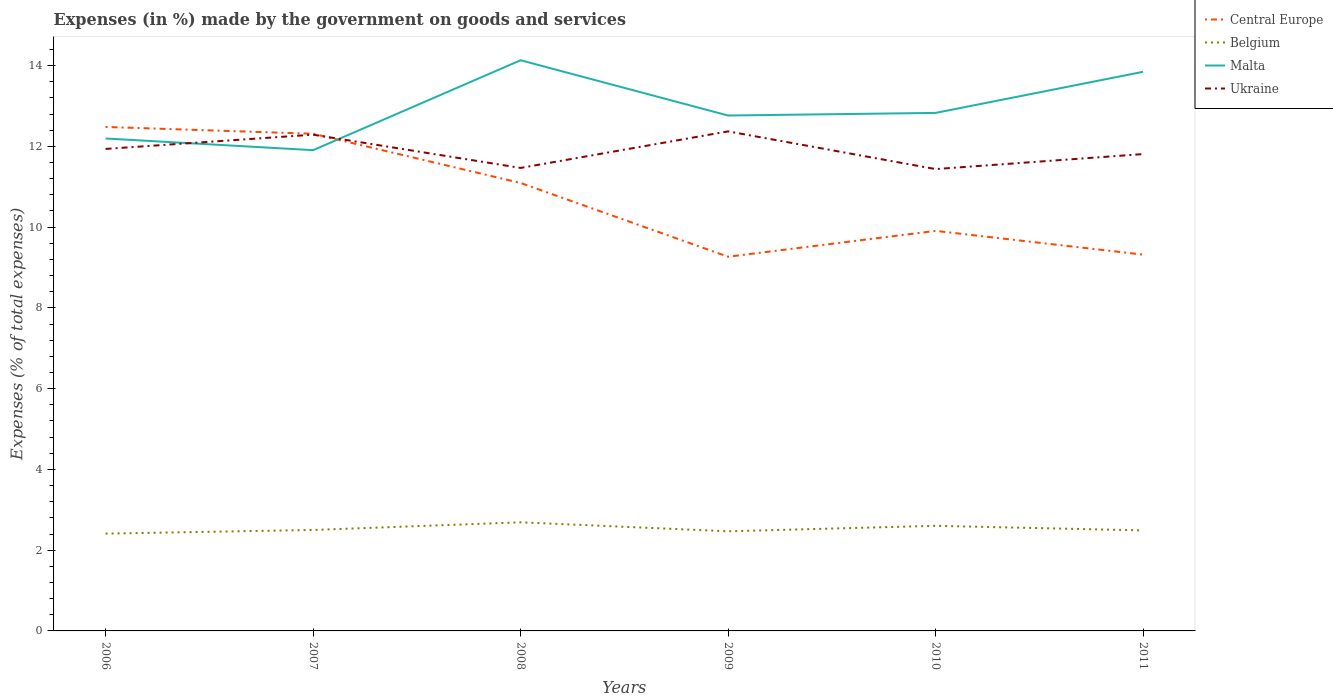How many different coloured lines are there?
Offer a very short reply. 4. Is the number of lines equal to the number of legend labels?
Your answer should be compact. Yes. Across all years, what is the maximum percentage of expenses made by the government on goods and services in Central Europe?
Make the answer very short. 9.27. In which year was the percentage of expenses made by the government on goods and services in Belgium maximum?
Ensure brevity in your answer.  2006. What is the total percentage of expenses made by the government on goods and services in Central Europe in the graph?
Make the answer very short. -0.05. What is the difference between the highest and the second highest percentage of expenses made by the government on goods and services in Ukraine?
Your response must be concise. 0.93. How many lines are there?
Ensure brevity in your answer.  4. Does the graph contain any zero values?
Make the answer very short. No. What is the title of the graph?
Your answer should be very brief. Expenses (in %) made by the government on goods and services. Does "East Asia (developing only)" appear as one of the legend labels in the graph?
Your answer should be compact. No. What is the label or title of the X-axis?
Your answer should be compact. Years. What is the label or title of the Y-axis?
Make the answer very short. Expenses (% of total expenses). What is the Expenses (% of total expenses) of Central Europe in 2006?
Your answer should be very brief. 12.48. What is the Expenses (% of total expenses) of Belgium in 2006?
Offer a very short reply. 2.41. What is the Expenses (% of total expenses) in Malta in 2006?
Offer a very short reply. 12.19. What is the Expenses (% of total expenses) of Ukraine in 2006?
Your answer should be compact. 11.94. What is the Expenses (% of total expenses) in Central Europe in 2007?
Your answer should be very brief. 12.31. What is the Expenses (% of total expenses) of Belgium in 2007?
Give a very brief answer. 2.5. What is the Expenses (% of total expenses) in Malta in 2007?
Provide a succinct answer. 11.91. What is the Expenses (% of total expenses) in Ukraine in 2007?
Your answer should be compact. 12.29. What is the Expenses (% of total expenses) in Central Europe in 2008?
Your answer should be compact. 11.09. What is the Expenses (% of total expenses) of Belgium in 2008?
Provide a short and direct response. 2.69. What is the Expenses (% of total expenses) in Malta in 2008?
Ensure brevity in your answer.  14.13. What is the Expenses (% of total expenses) of Ukraine in 2008?
Provide a short and direct response. 11.47. What is the Expenses (% of total expenses) in Central Europe in 2009?
Offer a very short reply. 9.27. What is the Expenses (% of total expenses) of Belgium in 2009?
Provide a succinct answer. 2.47. What is the Expenses (% of total expenses) in Malta in 2009?
Your response must be concise. 12.76. What is the Expenses (% of total expenses) in Ukraine in 2009?
Your answer should be very brief. 12.37. What is the Expenses (% of total expenses) in Central Europe in 2010?
Your answer should be very brief. 9.91. What is the Expenses (% of total expenses) in Belgium in 2010?
Offer a terse response. 2.6. What is the Expenses (% of total expenses) of Malta in 2010?
Make the answer very short. 12.83. What is the Expenses (% of total expenses) of Ukraine in 2010?
Make the answer very short. 11.44. What is the Expenses (% of total expenses) of Central Europe in 2011?
Offer a terse response. 9.32. What is the Expenses (% of total expenses) of Belgium in 2011?
Provide a succinct answer. 2.49. What is the Expenses (% of total expenses) of Malta in 2011?
Offer a very short reply. 13.85. What is the Expenses (% of total expenses) in Ukraine in 2011?
Your response must be concise. 11.81. Across all years, what is the maximum Expenses (% of total expenses) in Central Europe?
Make the answer very short. 12.48. Across all years, what is the maximum Expenses (% of total expenses) of Belgium?
Ensure brevity in your answer.  2.69. Across all years, what is the maximum Expenses (% of total expenses) of Malta?
Your answer should be very brief. 14.13. Across all years, what is the maximum Expenses (% of total expenses) of Ukraine?
Ensure brevity in your answer.  12.37. Across all years, what is the minimum Expenses (% of total expenses) in Central Europe?
Offer a terse response. 9.27. Across all years, what is the minimum Expenses (% of total expenses) in Belgium?
Your answer should be very brief. 2.41. Across all years, what is the minimum Expenses (% of total expenses) of Malta?
Your answer should be compact. 11.91. Across all years, what is the minimum Expenses (% of total expenses) of Ukraine?
Your response must be concise. 11.44. What is the total Expenses (% of total expenses) of Central Europe in the graph?
Your response must be concise. 64.37. What is the total Expenses (% of total expenses) of Belgium in the graph?
Provide a succinct answer. 15.16. What is the total Expenses (% of total expenses) of Malta in the graph?
Offer a terse response. 77.67. What is the total Expenses (% of total expenses) in Ukraine in the graph?
Your answer should be compact. 71.3. What is the difference between the Expenses (% of total expenses) in Central Europe in 2006 and that in 2007?
Give a very brief answer. 0.17. What is the difference between the Expenses (% of total expenses) of Belgium in 2006 and that in 2007?
Provide a succinct answer. -0.09. What is the difference between the Expenses (% of total expenses) in Malta in 2006 and that in 2007?
Offer a very short reply. 0.29. What is the difference between the Expenses (% of total expenses) of Ukraine in 2006 and that in 2007?
Your answer should be compact. -0.35. What is the difference between the Expenses (% of total expenses) of Central Europe in 2006 and that in 2008?
Your answer should be very brief. 1.39. What is the difference between the Expenses (% of total expenses) of Belgium in 2006 and that in 2008?
Offer a very short reply. -0.28. What is the difference between the Expenses (% of total expenses) in Malta in 2006 and that in 2008?
Ensure brevity in your answer.  -1.94. What is the difference between the Expenses (% of total expenses) of Ukraine in 2006 and that in 2008?
Keep it short and to the point. 0.47. What is the difference between the Expenses (% of total expenses) in Central Europe in 2006 and that in 2009?
Your answer should be compact. 3.21. What is the difference between the Expenses (% of total expenses) of Belgium in 2006 and that in 2009?
Ensure brevity in your answer.  -0.06. What is the difference between the Expenses (% of total expenses) of Malta in 2006 and that in 2009?
Offer a terse response. -0.57. What is the difference between the Expenses (% of total expenses) of Ukraine in 2006 and that in 2009?
Keep it short and to the point. -0.43. What is the difference between the Expenses (% of total expenses) of Central Europe in 2006 and that in 2010?
Offer a terse response. 2.57. What is the difference between the Expenses (% of total expenses) in Belgium in 2006 and that in 2010?
Your response must be concise. -0.19. What is the difference between the Expenses (% of total expenses) of Malta in 2006 and that in 2010?
Provide a succinct answer. -0.63. What is the difference between the Expenses (% of total expenses) in Ukraine in 2006 and that in 2010?
Your answer should be compact. 0.5. What is the difference between the Expenses (% of total expenses) in Central Europe in 2006 and that in 2011?
Keep it short and to the point. 3.16. What is the difference between the Expenses (% of total expenses) of Belgium in 2006 and that in 2011?
Your answer should be very brief. -0.08. What is the difference between the Expenses (% of total expenses) of Malta in 2006 and that in 2011?
Your response must be concise. -1.65. What is the difference between the Expenses (% of total expenses) in Ukraine in 2006 and that in 2011?
Keep it short and to the point. 0.13. What is the difference between the Expenses (% of total expenses) of Central Europe in 2007 and that in 2008?
Your response must be concise. 1.22. What is the difference between the Expenses (% of total expenses) in Belgium in 2007 and that in 2008?
Your response must be concise. -0.19. What is the difference between the Expenses (% of total expenses) in Malta in 2007 and that in 2008?
Provide a succinct answer. -2.23. What is the difference between the Expenses (% of total expenses) of Ukraine in 2007 and that in 2008?
Offer a very short reply. 0.82. What is the difference between the Expenses (% of total expenses) of Central Europe in 2007 and that in 2009?
Provide a short and direct response. 3.04. What is the difference between the Expenses (% of total expenses) of Belgium in 2007 and that in 2009?
Offer a terse response. 0.03. What is the difference between the Expenses (% of total expenses) of Malta in 2007 and that in 2009?
Your answer should be very brief. -0.86. What is the difference between the Expenses (% of total expenses) in Ukraine in 2007 and that in 2009?
Your answer should be compact. -0.08. What is the difference between the Expenses (% of total expenses) of Central Europe in 2007 and that in 2010?
Keep it short and to the point. 2.4. What is the difference between the Expenses (% of total expenses) of Belgium in 2007 and that in 2010?
Make the answer very short. -0.1. What is the difference between the Expenses (% of total expenses) of Malta in 2007 and that in 2010?
Ensure brevity in your answer.  -0.92. What is the difference between the Expenses (% of total expenses) of Ukraine in 2007 and that in 2010?
Provide a short and direct response. 0.85. What is the difference between the Expenses (% of total expenses) of Central Europe in 2007 and that in 2011?
Ensure brevity in your answer.  2.99. What is the difference between the Expenses (% of total expenses) in Belgium in 2007 and that in 2011?
Offer a very short reply. 0.01. What is the difference between the Expenses (% of total expenses) in Malta in 2007 and that in 2011?
Keep it short and to the point. -1.94. What is the difference between the Expenses (% of total expenses) in Ukraine in 2007 and that in 2011?
Ensure brevity in your answer.  0.48. What is the difference between the Expenses (% of total expenses) in Central Europe in 2008 and that in 2009?
Keep it short and to the point. 1.83. What is the difference between the Expenses (% of total expenses) of Belgium in 2008 and that in 2009?
Your response must be concise. 0.22. What is the difference between the Expenses (% of total expenses) of Malta in 2008 and that in 2009?
Offer a very short reply. 1.37. What is the difference between the Expenses (% of total expenses) in Ukraine in 2008 and that in 2009?
Your answer should be compact. -0.91. What is the difference between the Expenses (% of total expenses) in Central Europe in 2008 and that in 2010?
Your answer should be very brief. 1.19. What is the difference between the Expenses (% of total expenses) of Belgium in 2008 and that in 2010?
Your response must be concise. 0.09. What is the difference between the Expenses (% of total expenses) of Malta in 2008 and that in 2010?
Offer a very short reply. 1.3. What is the difference between the Expenses (% of total expenses) of Ukraine in 2008 and that in 2010?
Give a very brief answer. 0.03. What is the difference between the Expenses (% of total expenses) of Central Europe in 2008 and that in 2011?
Keep it short and to the point. 1.77. What is the difference between the Expenses (% of total expenses) in Belgium in 2008 and that in 2011?
Your response must be concise. 0.2. What is the difference between the Expenses (% of total expenses) in Malta in 2008 and that in 2011?
Provide a short and direct response. 0.29. What is the difference between the Expenses (% of total expenses) of Ukraine in 2008 and that in 2011?
Keep it short and to the point. -0.34. What is the difference between the Expenses (% of total expenses) of Central Europe in 2009 and that in 2010?
Offer a very short reply. -0.64. What is the difference between the Expenses (% of total expenses) of Belgium in 2009 and that in 2010?
Offer a terse response. -0.14. What is the difference between the Expenses (% of total expenses) of Malta in 2009 and that in 2010?
Your response must be concise. -0.06. What is the difference between the Expenses (% of total expenses) of Ukraine in 2009 and that in 2010?
Offer a very short reply. 0.93. What is the difference between the Expenses (% of total expenses) of Central Europe in 2009 and that in 2011?
Provide a succinct answer. -0.05. What is the difference between the Expenses (% of total expenses) in Belgium in 2009 and that in 2011?
Your answer should be very brief. -0.02. What is the difference between the Expenses (% of total expenses) in Malta in 2009 and that in 2011?
Your answer should be compact. -1.08. What is the difference between the Expenses (% of total expenses) of Ukraine in 2009 and that in 2011?
Ensure brevity in your answer.  0.56. What is the difference between the Expenses (% of total expenses) in Central Europe in 2010 and that in 2011?
Ensure brevity in your answer.  0.59. What is the difference between the Expenses (% of total expenses) in Belgium in 2010 and that in 2011?
Provide a succinct answer. 0.11. What is the difference between the Expenses (% of total expenses) of Malta in 2010 and that in 2011?
Offer a very short reply. -1.02. What is the difference between the Expenses (% of total expenses) of Ukraine in 2010 and that in 2011?
Keep it short and to the point. -0.37. What is the difference between the Expenses (% of total expenses) of Central Europe in 2006 and the Expenses (% of total expenses) of Belgium in 2007?
Provide a short and direct response. 9.98. What is the difference between the Expenses (% of total expenses) of Central Europe in 2006 and the Expenses (% of total expenses) of Malta in 2007?
Make the answer very short. 0.57. What is the difference between the Expenses (% of total expenses) of Central Europe in 2006 and the Expenses (% of total expenses) of Ukraine in 2007?
Provide a succinct answer. 0.19. What is the difference between the Expenses (% of total expenses) of Belgium in 2006 and the Expenses (% of total expenses) of Malta in 2007?
Offer a terse response. -9.5. What is the difference between the Expenses (% of total expenses) of Belgium in 2006 and the Expenses (% of total expenses) of Ukraine in 2007?
Provide a short and direct response. -9.88. What is the difference between the Expenses (% of total expenses) of Malta in 2006 and the Expenses (% of total expenses) of Ukraine in 2007?
Offer a very short reply. -0.09. What is the difference between the Expenses (% of total expenses) in Central Europe in 2006 and the Expenses (% of total expenses) in Belgium in 2008?
Your answer should be very brief. 9.79. What is the difference between the Expenses (% of total expenses) of Central Europe in 2006 and the Expenses (% of total expenses) of Malta in 2008?
Give a very brief answer. -1.65. What is the difference between the Expenses (% of total expenses) in Central Europe in 2006 and the Expenses (% of total expenses) in Ukraine in 2008?
Your answer should be very brief. 1.01. What is the difference between the Expenses (% of total expenses) of Belgium in 2006 and the Expenses (% of total expenses) of Malta in 2008?
Make the answer very short. -11.72. What is the difference between the Expenses (% of total expenses) of Belgium in 2006 and the Expenses (% of total expenses) of Ukraine in 2008?
Give a very brief answer. -9.06. What is the difference between the Expenses (% of total expenses) of Malta in 2006 and the Expenses (% of total expenses) of Ukraine in 2008?
Your answer should be compact. 0.73. What is the difference between the Expenses (% of total expenses) of Central Europe in 2006 and the Expenses (% of total expenses) of Belgium in 2009?
Your response must be concise. 10.01. What is the difference between the Expenses (% of total expenses) of Central Europe in 2006 and the Expenses (% of total expenses) of Malta in 2009?
Ensure brevity in your answer.  -0.28. What is the difference between the Expenses (% of total expenses) in Central Europe in 2006 and the Expenses (% of total expenses) in Ukraine in 2009?
Offer a very short reply. 0.11. What is the difference between the Expenses (% of total expenses) in Belgium in 2006 and the Expenses (% of total expenses) in Malta in 2009?
Your response must be concise. -10.35. What is the difference between the Expenses (% of total expenses) of Belgium in 2006 and the Expenses (% of total expenses) of Ukraine in 2009?
Your answer should be compact. -9.96. What is the difference between the Expenses (% of total expenses) in Malta in 2006 and the Expenses (% of total expenses) in Ukraine in 2009?
Keep it short and to the point. -0.18. What is the difference between the Expenses (% of total expenses) of Central Europe in 2006 and the Expenses (% of total expenses) of Belgium in 2010?
Your response must be concise. 9.88. What is the difference between the Expenses (% of total expenses) of Central Europe in 2006 and the Expenses (% of total expenses) of Malta in 2010?
Keep it short and to the point. -0.35. What is the difference between the Expenses (% of total expenses) in Central Europe in 2006 and the Expenses (% of total expenses) in Ukraine in 2010?
Provide a succinct answer. 1.04. What is the difference between the Expenses (% of total expenses) in Belgium in 2006 and the Expenses (% of total expenses) in Malta in 2010?
Your response must be concise. -10.42. What is the difference between the Expenses (% of total expenses) in Belgium in 2006 and the Expenses (% of total expenses) in Ukraine in 2010?
Your answer should be very brief. -9.03. What is the difference between the Expenses (% of total expenses) of Malta in 2006 and the Expenses (% of total expenses) of Ukraine in 2010?
Your answer should be compact. 0.76. What is the difference between the Expenses (% of total expenses) of Central Europe in 2006 and the Expenses (% of total expenses) of Belgium in 2011?
Provide a succinct answer. 9.99. What is the difference between the Expenses (% of total expenses) of Central Europe in 2006 and the Expenses (% of total expenses) of Malta in 2011?
Provide a succinct answer. -1.37. What is the difference between the Expenses (% of total expenses) of Central Europe in 2006 and the Expenses (% of total expenses) of Ukraine in 2011?
Your answer should be very brief. 0.67. What is the difference between the Expenses (% of total expenses) in Belgium in 2006 and the Expenses (% of total expenses) in Malta in 2011?
Your response must be concise. -11.44. What is the difference between the Expenses (% of total expenses) in Belgium in 2006 and the Expenses (% of total expenses) in Ukraine in 2011?
Make the answer very short. -9.4. What is the difference between the Expenses (% of total expenses) of Malta in 2006 and the Expenses (% of total expenses) of Ukraine in 2011?
Give a very brief answer. 0.39. What is the difference between the Expenses (% of total expenses) in Central Europe in 2007 and the Expenses (% of total expenses) in Belgium in 2008?
Ensure brevity in your answer.  9.62. What is the difference between the Expenses (% of total expenses) in Central Europe in 2007 and the Expenses (% of total expenses) in Malta in 2008?
Your response must be concise. -1.82. What is the difference between the Expenses (% of total expenses) of Central Europe in 2007 and the Expenses (% of total expenses) of Ukraine in 2008?
Provide a succinct answer. 0.85. What is the difference between the Expenses (% of total expenses) in Belgium in 2007 and the Expenses (% of total expenses) in Malta in 2008?
Your answer should be compact. -11.63. What is the difference between the Expenses (% of total expenses) of Belgium in 2007 and the Expenses (% of total expenses) of Ukraine in 2008?
Your answer should be compact. -8.96. What is the difference between the Expenses (% of total expenses) of Malta in 2007 and the Expenses (% of total expenses) of Ukraine in 2008?
Your response must be concise. 0.44. What is the difference between the Expenses (% of total expenses) in Central Europe in 2007 and the Expenses (% of total expenses) in Belgium in 2009?
Make the answer very short. 9.84. What is the difference between the Expenses (% of total expenses) in Central Europe in 2007 and the Expenses (% of total expenses) in Malta in 2009?
Your answer should be compact. -0.45. What is the difference between the Expenses (% of total expenses) in Central Europe in 2007 and the Expenses (% of total expenses) in Ukraine in 2009?
Your response must be concise. -0.06. What is the difference between the Expenses (% of total expenses) in Belgium in 2007 and the Expenses (% of total expenses) in Malta in 2009?
Make the answer very short. -10.26. What is the difference between the Expenses (% of total expenses) of Belgium in 2007 and the Expenses (% of total expenses) of Ukraine in 2009?
Give a very brief answer. -9.87. What is the difference between the Expenses (% of total expenses) in Malta in 2007 and the Expenses (% of total expenses) in Ukraine in 2009?
Give a very brief answer. -0.47. What is the difference between the Expenses (% of total expenses) in Central Europe in 2007 and the Expenses (% of total expenses) in Belgium in 2010?
Ensure brevity in your answer.  9.71. What is the difference between the Expenses (% of total expenses) of Central Europe in 2007 and the Expenses (% of total expenses) of Malta in 2010?
Your response must be concise. -0.52. What is the difference between the Expenses (% of total expenses) in Central Europe in 2007 and the Expenses (% of total expenses) in Ukraine in 2010?
Offer a terse response. 0.87. What is the difference between the Expenses (% of total expenses) in Belgium in 2007 and the Expenses (% of total expenses) in Malta in 2010?
Provide a succinct answer. -10.33. What is the difference between the Expenses (% of total expenses) in Belgium in 2007 and the Expenses (% of total expenses) in Ukraine in 2010?
Your answer should be very brief. -8.94. What is the difference between the Expenses (% of total expenses) of Malta in 2007 and the Expenses (% of total expenses) of Ukraine in 2010?
Make the answer very short. 0.47. What is the difference between the Expenses (% of total expenses) of Central Europe in 2007 and the Expenses (% of total expenses) of Belgium in 2011?
Provide a short and direct response. 9.82. What is the difference between the Expenses (% of total expenses) in Central Europe in 2007 and the Expenses (% of total expenses) in Malta in 2011?
Your response must be concise. -1.53. What is the difference between the Expenses (% of total expenses) in Central Europe in 2007 and the Expenses (% of total expenses) in Ukraine in 2011?
Give a very brief answer. 0.5. What is the difference between the Expenses (% of total expenses) in Belgium in 2007 and the Expenses (% of total expenses) in Malta in 2011?
Keep it short and to the point. -11.35. What is the difference between the Expenses (% of total expenses) in Belgium in 2007 and the Expenses (% of total expenses) in Ukraine in 2011?
Your answer should be very brief. -9.31. What is the difference between the Expenses (% of total expenses) in Malta in 2007 and the Expenses (% of total expenses) in Ukraine in 2011?
Your answer should be very brief. 0.1. What is the difference between the Expenses (% of total expenses) of Central Europe in 2008 and the Expenses (% of total expenses) of Belgium in 2009?
Provide a short and direct response. 8.63. What is the difference between the Expenses (% of total expenses) in Central Europe in 2008 and the Expenses (% of total expenses) in Malta in 2009?
Your answer should be very brief. -1.67. What is the difference between the Expenses (% of total expenses) in Central Europe in 2008 and the Expenses (% of total expenses) in Ukraine in 2009?
Offer a very short reply. -1.28. What is the difference between the Expenses (% of total expenses) of Belgium in 2008 and the Expenses (% of total expenses) of Malta in 2009?
Your response must be concise. -10.07. What is the difference between the Expenses (% of total expenses) in Belgium in 2008 and the Expenses (% of total expenses) in Ukraine in 2009?
Your answer should be very brief. -9.68. What is the difference between the Expenses (% of total expenses) in Malta in 2008 and the Expenses (% of total expenses) in Ukraine in 2009?
Your response must be concise. 1.76. What is the difference between the Expenses (% of total expenses) in Central Europe in 2008 and the Expenses (% of total expenses) in Belgium in 2010?
Provide a succinct answer. 8.49. What is the difference between the Expenses (% of total expenses) of Central Europe in 2008 and the Expenses (% of total expenses) of Malta in 2010?
Offer a terse response. -1.74. What is the difference between the Expenses (% of total expenses) of Central Europe in 2008 and the Expenses (% of total expenses) of Ukraine in 2010?
Offer a very short reply. -0.34. What is the difference between the Expenses (% of total expenses) of Belgium in 2008 and the Expenses (% of total expenses) of Malta in 2010?
Make the answer very short. -10.14. What is the difference between the Expenses (% of total expenses) of Belgium in 2008 and the Expenses (% of total expenses) of Ukraine in 2010?
Your answer should be very brief. -8.75. What is the difference between the Expenses (% of total expenses) of Malta in 2008 and the Expenses (% of total expenses) of Ukraine in 2010?
Offer a very short reply. 2.7. What is the difference between the Expenses (% of total expenses) of Central Europe in 2008 and the Expenses (% of total expenses) of Belgium in 2011?
Offer a very short reply. 8.6. What is the difference between the Expenses (% of total expenses) of Central Europe in 2008 and the Expenses (% of total expenses) of Malta in 2011?
Provide a succinct answer. -2.75. What is the difference between the Expenses (% of total expenses) in Central Europe in 2008 and the Expenses (% of total expenses) in Ukraine in 2011?
Your response must be concise. -0.72. What is the difference between the Expenses (% of total expenses) of Belgium in 2008 and the Expenses (% of total expenses) of Malta in 2011?
Ensure brevity in your answer.  -11.16. What is the difference between the Expenses (% of total expenses) in Belgium in 2008 and the Expenses (% of total expenses) in Ukraine in 2011?
Offer a terse response. -9.12. What is the difference between the Expenses (% of total expenses) of Malta in 2008 and the Expenses (% of total expenses) of Ukraine in 2011?
Offer a terse response. 2.32. What is the difference between the Expenses (% of total expenses) of Central Europe in 2009 and the Expenses (% of total expenses) of Belgium in 2010?
Ensure brevity in your answer.  6.66. What is the difference between the Expenses (% of total expenses) in Central Europe in 2009 and the Expenses (% of total expenses) in Malta in 2010?
Your answer should be very brief. -3.56. What is the difference between the Expenses (% of total expenses) of Central Europe in 2009 and the Expenses (% of total expenses) of Ukraine in 2010?
Offer a terse response. -2.17. What is the difference between the Expenses (% of total expenses) in Belgium in 2009 and the Expenses (% of total expenses) in Malta in 2010?
Keep it short and to the point. -10.36. What is the difference between the Expenses (% of total expenses) in Belgium in 2009 and the Expenses (% of total expenses) in Ukraine in 2010?
Ensure brevity in your answer.  -8.97. What is the difference between the Expenses (% of total expenses) in Malta in 2009 and the Expenses (% of total expenses) in Ukraine in 2010?
Provide a short and direct response. 1.33. What is the difference between the Expenses (% of total expenses) in Central Europe in 2009 and the Expenses (% of total expenses) in Belgium in 2011?
Provide a short and direct response. 6.78. What is the difference between the Expenses (% of total expenses) of Central Europe in 2009 and the Expenses (% of total expenses) of Malta in 2011?
Give a very brief answer. -4.58. What is the difference between the Expenses (% of total expenses) in Central Europe in 2009 and the Expenses (% of total expenses) in Ukraine in 2011?
Your answer should be compact. -2.54. What is the difference between the Expenses (% of total expenses) in Belgium in 2009 and the Expenses (% of total expenses) in Malta in 2011?
Ensure brevity in your answer.  -11.38. What is the difference between the Expenses (% of total expenses) of Belgium in 2009 and the Expenses (% of total expenses) of Ukraine in 2011?
Keep it short and to the point. -9.34. What is the difference between the Expenses (% of total expenses) of Malta in 2009 and the Expenses (% of total expenses) of Ukraine in 2011?
Offer a terse response. 0.95. What is the difference between the Expenses (% of total expenses) in Central Europe in 2010 and the Expenses (% of total expenses) in Belgium in 2011?
Give a very brief answer. 7.42. What is the difference between the Expenses (% of total expenses) in Central Europe in 2010 and the Expenses (% of total expenses) in Malta in 2011?
Ensure brevity in your answer.  -3.94. What is the difference between the Expenses (% of total expenses) in Central Europe in 2010 and the Expenses (% of total expenses) in Ukraine in 2011?
Offer a very short reply. -1.9. What is the difference between the Expenses (% of total expenses) of Belgium in 2010 and the Expenses (% of total expenses) of Malta in 2011?
Offer a very short reply. -11.24. What is the difference between the Expenses (% of total expenses) in Belgium in 2010 and the Expenses (% of total expenses) in Ukraine in 2011?
Your answer should be compact. -9.21. What is the difference between the Expenses (% of total expenses) of Malta in 2010 and the Expenses (% of total expenses) of Ukraine in 2011?
Ensure brevity in your answer.  1.02. What is the average Expenses (% of total expenses) in Central Europe per year?
Keep it short and to the point. 10.73. What is the average Expenses (% of total expenses) of Belgium per year?
Make the answer very short. 2.53. What is the average Expenses (% of total expenses) of Malta per year?
Give a very brief answer. 12.94. What is the average Expenses (% of total expenses) of Ukraine per year?
Give a very brief answer. 11.88. In the year 2006, what is the difference between the Expenses (% of total expenses) of Central Europe and Expenses (% of total expenses) of Belgium?
Ensure brevity in your answer.  10.07. In the year 2006, what is the difference between the Expenses (% of total expenses) of Central Europe and Expenses (% of total expenses) of Malta?
Keep it short and to the point. 0.29. In the year 2006, what is the difference between the Expenses (% of total expenses) in Central Europe and Expenses (% of total expenses) in Ukraine?
Provide a succinct answer. 0.54. In the year 2006, what is the difference between the Expenses (% of total expenses) of Belgium and Expenses (% of total expenses) of Malta?
Your answer should be compact. -9.79. In the year 2006, what is the difference between the Expenses (% of total expenses) of Belgium and Expenses (% of total expenses) of Ukraine?
Your response must be concise. -9.53. In the year 2006, what is the difference between the Expenses (% of total expenses) in Malta and Expenses (% of total expenses) in Ukraine?
Offer a terse response. 0.26. In the year 2007, what is the difference between the Expenses (% of total expenses) in Central Europe and Expenses (% of total expenses) in Belgium?
Keep it short and to the point. 9.81. In the year 2007, what is the difference between the Expenses (% of total expenses) in Central Europe and Expenses (% of total expenses) in Malta?
Your answer should be compact. 0.41. In the year 2007, what is the difference between the Expenses (% of total expenses) in Central Europe and Expenses (% of total expenses) in Ukraine?
Your answer should be compact. 0.02. In the year 2007, what is the difference between the Expenses (% of total expenses) in Belgium and Expenses (% of total expenses) in Malta?
Make the answer very short. -9.4. In the year 2007, what is the difference between the Expenses (% of total expenses) of Belgium and Expenses (% of total expenses) of Ukraine?
Make the answer very short. -9.79. In the year 2007, what is the difference between the Expenses (% of total expenses) in Malta and Expenses (% of total expenses) in Ukraine?
Your answer should be compact. -0.38. In the year 2008, what is the difference between the Expenses (% of total expenses) of Central Europe and Expenses (% of total expenses) of Belgium?
Make the answer very short. 8.4. In the year 2008, what is the difference between the Expenses (% of total expenses) in Central Europe and Expenses (% of total expenses) in Malta?
Offer a very short reply. -3.04. In the year 2008, what is the difference between the Expenses (% of total expenses) of Central Europe and Expenses (% of total expenses) of Ukraine?
Provide a succinct answer. -0.37. In the year 2008, what is the difference between the Expenses (% of total expenses) of Belgium and Expenses (% of total expenses) of Malta?
Your response must be concise. -11.44. In the year 2008, what is the difference between the Expenses (% of total expenses) in Belgium and Expenses (% of total expenses) in Ukraine?
Make the answer very short. -8.78. In the year 2008, what is the difference between the Expenses (% of total expenses) in Malta and Expenses (% of total expenses) in Ukraine?
Your answer should be very brief. 2.67. In the year 2009, what is the difference between the Expenses (% of total expenses) in Central Europe and Expenses (% of total expenses) in Belgium?
Your answer should be compact. 6.8. In the year 2009, what is the difference between the Expenses (% of total expenses) of Central Europe and Expenses (% of total expenses) of Malta?
Make the answer very short. -3.5. In the year 2009, what is the difference between the Expenses (% of total expenses) in Central Europe and Expenses (% of total expenses) in Ukraine?
Provide a short and direct response. -3.1. In the year 2009, what is the difference between the Expenses (% of total expenses) of Belgium and Expenses (% of total expenses) of Malta?
Your answer should be compact. -10.3. In the year 2009, what is the difference between the Expenses (% of total expenses) of Belgium and Expenses (% of total expenses) of Ukraine?
Provide a succinct answer. -9.9. In the year 2009, what is the difference between the Expenses (% of total expenses) of Malta and Expenses (% of total expenses) of Ukraine?
Offer a terse response. 0.39. In the year 2010, what is the difference between the Expenses (% of total expenses) in Central Europe and Expenses (% of total expenses) in Belgium?
Give a very brief answer. 7.3. In the year 2010, what is the difference between the Expenses (% of total expenses) in Central Europe and Expenses (% of total expenses) in Malta?
Keep it short and to the point. -2.92. In the year 2010, what is the difference between the Expenses (% of total expenses) of Central Europe and Expenses (% of total expenses) of Ukraine?
Give a very brief answer. -1.53. In the year 2010, what is the difference between the Expenses (% of total expenses) of Belgium and Expenses (% of total expenses) of Malta?
Make the answer very short. -10.22. In the year 2010, what is the difference between the Expenses (% of total expenses) of Belgium and Expenses (% of total expenses) of Ukraine?
Offer a terse response. -8.83. In the year 2010, what is the difference between the Expenses (% of total expenses) in Malta and Expenses (% of total expenses) in Ukraine?
Offer a terse response. 1.39. In the year 2011, what is the difference between the Expenses (% of total expenses) in Central Europe and Expenses (% of total expenses) in Belgium?
Your answer should be very brief. 6.83. In the year 2011, what is the difference between the Expenses (% of total expenses) of Central Europe and Expenses (% of total expenses) of Malta?
Give a very brief answer. -4.53. In the year 2011, what is the difference between the Expenses (% of total expenses) of Central Europe and Expenses (% of total expenses) of Ukraine?
Give a very brief answer. -2.49. In the year 2011, what is the difference between the Expenses (% of total expenses) of Belgium and Expenses (% of total expenses) of Malta?
Ensure brevity in your answer.  -11.36. In the year 2011, what is the difference between the Expenses (% of total expenses) of Belgium and Expenses (% of total expenses) of Ukraine?
Offer a very short reply. -9.32. In the year 2011, what is the difference between the Expenses (% of total expenses) of Malta and Expenses (% of total expenses) of Ukraine?
Keep it short and to the point. 2.04. What is the ratio of the Expenses (% of total expenses) of Central Europe in 2006 to that in 2007?
Keep it short and to the point. 1.01. What is the ratio of the Expenses (% of total expenses) of Belgium in 2006 to that in 2007?
Keep it short and to the point. 0.96. What is the ratio of the Expenses (% of total expenses) of Malta in 2006 to that in 2007?
Offer a terse response. 1.02. What is the ratio of the Expenses (% of total expenses) of Ukraine in 2006 to that in 2007?
Make the answer very short. 0.97. What is the ratio of the Expenses (% of total expenses) of Central Europe in 2006 to that in 2008?
Your answer should be very brief. 1.13. What is the ratio of the Expenses (% of total expenses) of Belgium in 2006 to that in 2008?
Your response must be concise. 0.9. What is the ratio of the Expenses (% of total expenses) of Malta in 2006 to that in 2008?
Your answer should be very brief. 0.86. What is the ratio of the Expenses (% of total expenses) in Ukraine in 2006 to that in 2008?
Provide a succinct answer. 1.04. What is the ratio of the Expenses (% of total expenses) of Central Europe in 2006 to that in 2009?
Ensure brevity in your answer.  1.35. What is the ratio of the Expenses (% of total expenses) in Belgium in 2006 to that in 2009?
Offer a very short reply. 0.98. What is the ratio of the Expenses (% of total expenses) in Malta in 2006 to that in 2009?
Provide a succinct answer. 0.96. What is the ratio of the Expenses (% of total expenses) of Ukraine in 2006 to that in 2009?
Keep it short and to the point. 0.96. What is the ratio of the Expenses (% of total expenses) of Central Europe in 2006 to that in 2010?
Keep it short and to the point. 1.26. What is the ratio of the Expenses (% of total expenses) of Belgium in 2006 to that in 2010?
Offer a very short reply. 0.93. What is the ratio of the Expenses (% of total expenses) of Malta in 2006 to that in 2010?
Your answer should be compact. 0.95. What is the ratio of the Expenses (% of total expenses) of Ukraine in 2006 to that in 2010?
Your answer should be very brief. 1.04. What is the ratio of the Expenses (% of total expenses) of Central Europe in 2006 to that in 2011?
Provide a succinct answer. 1.34. What is the ratio of the Expenses (% of total expenses) in Belgium in 2006 to that in 2011?
Offer a very short reply. 0.97. What is the ratio of the Expenses (% of total expenses) of Malta in 2006 to that in 2011?
Ensure brevity in your answer.  0.88. What is the ratio of the Expenses (% of total expenses) of Ukraine in 2006 to that in 2011?
Give a very brief answer. 1.01. What is the ratio of the Expenses (% of total expenses) in Central Europe in 2007 to that in 2008?
Your answer should be very brief. 1.11. What is the ratio of the Expenses (% of total expenses) of Belgium in 2007 to that in 2008?
Offer a very short reply. 0.93. What is the ratio of the Expenses (% of total expenses) of Malta in 2007 to that in 2008?
Provide a succinct answer. 0.84. What is the ratio of the Expenses (% of total expenses) in Ukraine in 2007 to that in 2008?
Give a very brief answer. 1.07. What is the ratio of the Expenses (% of total expenses) in Central Europe in 2007 to that in 2009?
Your answer should be very brief. 1.33. What is the ratio of the Expenses (% of total expenses) of Belgium in 2007 to that in 2009?
Give a very brief answer. 1.01. What is the ratio of the Expenses (% of total expenses) of Malta in 2007 to that in 2009?
Offer a very short reply. 0.93. What is the ratio of the Expenses (% of total expenses) in Ukraine in 2007 to that in 2009?
Give a very brief answer. 0.99. What is the ratio of the Expenses (% of total expenses) in Central Europe in 2007 to that in 2010?
Keep it short and to the point. 1.24. What is the ratio of the Expenses (% of total expenses) in Belgium in 2007 to that in 2010?
Offer a very short reply. 0.96. What is the ratio of the Expenses (% of total expenses) of Malta in 2007 to that in 2010?
Give a very brief answer. 0.93. What is the ratio of the Expenses (% of total expenses) in Ukraine in 2007 to that in 2010?
Your answer should be compact. 1.07. What is the ratio of the Expenses (% of total expenses) of Central Europe in 2007 to that in 2011?
Keep it short and to the point. 1.32. What is the ratio of the Expenses (% of total expenses) in Malta in 2007 to that in 2011?
Offer a terse response. 0.86. What is the ratio of the Expenses (% of total expenses) in Ukraine in 2007 to that in 2011?
Provide a short and direct response. 1.04. What is the ratio of the Expenses (% of total expenses) of Central Europe in 2008 to that in 2009?
Keep it short and to the point. 1.2. What is the ratio of the Expenses (% of total expenses) in Belgium in 2008 to that in 2009?
Give a very brief answer. 1.09. What is the ratio of the Expenses (% of total expenses) in Malta in 2008 to that in 2009?
Offer a very short reply. 1.11. What is the ratio of the Expenses (% of total expenses) in Ukraine in 2008 to that in 2009?
Provide a short and direct response. 0.93. What is the ratio of the Expenses (% of total expenses) in Central Europe in 2008 to that in 2010?
Give a very brief answer. 1.12. What is the ratio of the Expenses (% of total expenses) in Belgium in 2008 to that in 2010?
Give a very brief answer. 1.03. What is the ratio of the Expenses (% of total expenses) in Malta in 2008 to that in 2010?
Provide a succinct answer. 1.1. What is the ratio of the Expenses (% of total expenses) of Ukraine in 2008 to that in 2010?
Keep it short and to the point. 1. What is the ratio of the Expenses (% of total expenses) in Central Europe in 2008 to that in 2011?
Make the answer very short. 1.19. What is the ratio of the Expenses (% of total expenses) of Belgium in 2008 to that in 2011?
Provide a short and direct response. 1.08. What is the ratio of the Expenses (% of total expenses) of Malta in 2008 to that in 2011?
Your answer should be very brief. 1.02. What is the ratio of the Expenses (% of total expenses) of Ukraine in 2008 to that in 2011?
Offer a very short reply. 0.97. What is the ratio of the Expenses (% of total expenses) of Central Europe in 2009 to that in 2010?
Offer a terse response. 0.94. What is the ratio of the Expenses (% of total expenses) of Belgium in 2009 to that in 2010?
Provide a short and direct response. 0.95. What is the ratio of the Expenses (% of total expenses) of Malta in 2009 to that in 2010?
Keep it short and to the point. 0.99. What is the ratio of the Expenses (% of total expenses) of Ukraine in 2009 to that in 2010?
Make the answer very short. 1.08. What is the ratio of the Expenses (% of total expenses) of Malta in 2009 to that in 2011?
Your response must be concise. 0.92. What is the ratio of the Expenses (% of total expenses) of Ukraine in 2009 to that in 2011?
Make the answer very short. 1.05. What is the ratio of the Expenses (% of total expenses) of Central Europe in 2010 to that in 2011?
Make the answer very short. 1.06. What is the ratio of the Expenses (% of total expenses) of Belgium in 2010 to that in 2011?
Give a very brief answer. 1.05. What is the ratio of the Expenses (% of total expenses) in Malta in 2010 to that in 2011?
Offer a very short reply. 0.93. What is the ratio of the Expenses (% of total expenses) of Ukraine in 2010 to that in 2011?
Keep it short and to the point. 0.97. What is the difference between the highest and the second highest Expenses (% of total expenses) of Central Europe?
Keep it short and to the point. 0.17. What is the difference between the highest and the second highest Expenses (% of total expenses) of Belgium?
Ensure brevity in your answer.  0.09. What is the difference between the highest and the second highest Expenses (% of total expenses) in Malta?
Provide a short and direct response. 0.29. What is the difference between the highest and the second highest Expenses (% of total expenses) of Ukraine?
Your answer should be compact. 0.08. What is the difference between the highest and the lowest Expenses (% of total expenses) of Central Europe?
Your answer should be compact. 3.21. What is the difference between the highest and the lowest Expenses (% of total expenses) in Belgium?
Provide a short and direct response. 0.28. What is the difference between the highest and the lowest Expenses (% of total expenses) of Malta?
Keep it short and to the point. 2.23. What is the difference between the highest and the lowest Expenses (% of total expenses) in Ukraine?
Your answer should be very brief. 0.93. 